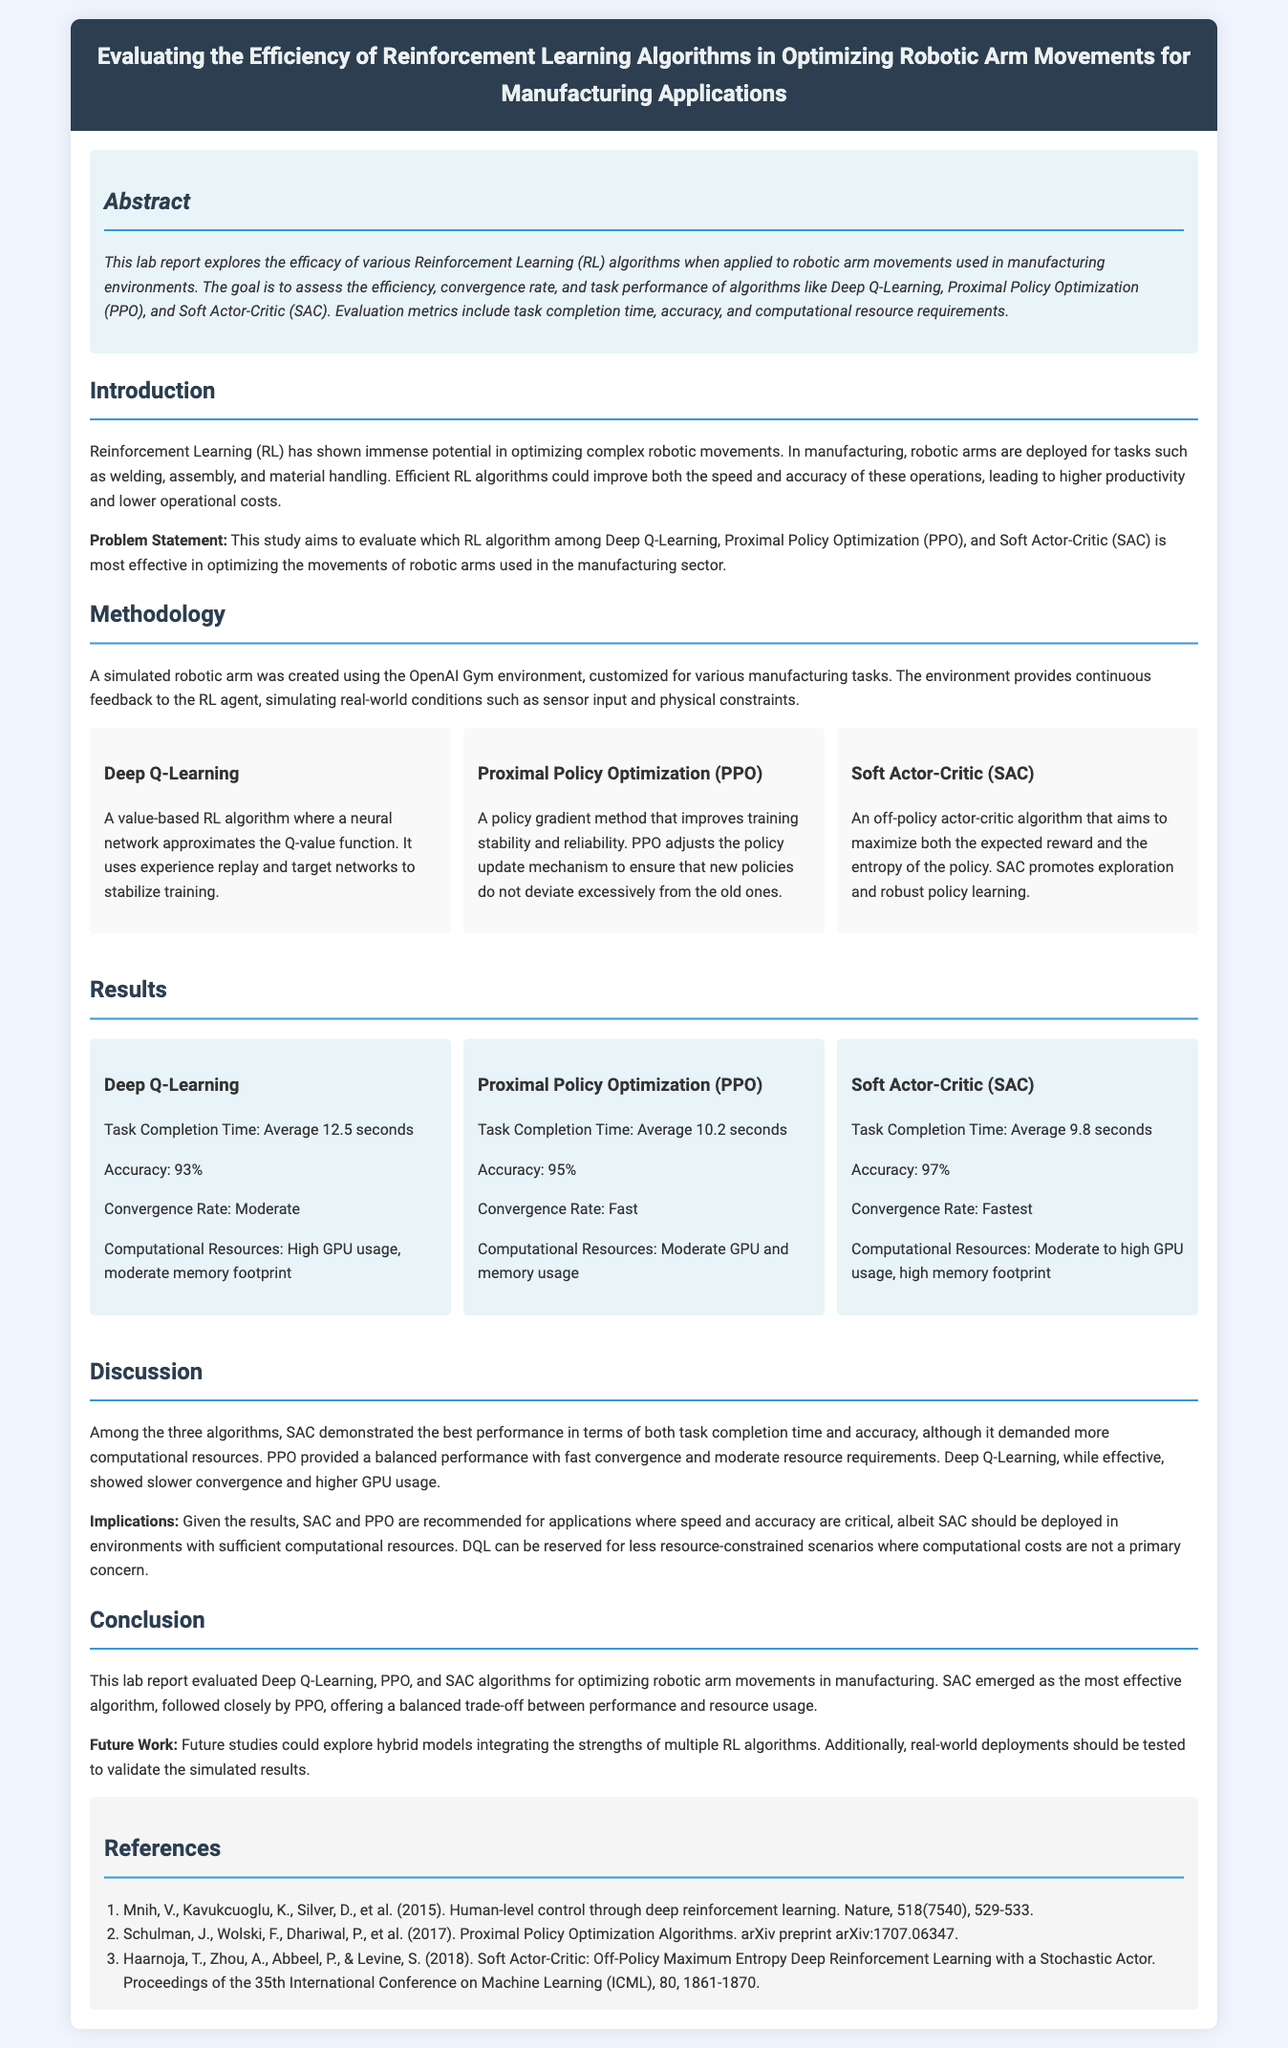What is the title of the lab report? The title of the lab report is stated at the top of the document.
Answer: Evaluating the Efficiency of Reinforcement Learning Algorithms in Optimizing Robotic Arm Movements for Manufacturing Applications What are the three algorithms evaluated in this report? The algorithms are mentioned in the Methodology section of the document.
Answer: Deep Q-Learning, Proximal Policy Optimization (PPO), Soft Actor-Critic (SAC) What was the average task completion time for Soft Actor-Critic? The average task completion time for SAC is found in the Results section of the document.
Answer: 9.8 seconds Which algorithm had the highest accuracy? The accuracy for each algorithm is listed in their respective result cards in the Results section.
Answer: Soft Actor-Critic (SAC) What is the recommended algorithm for limited computational resources? The recommendation is found in the Discussion section of the document when comparing the algorithms.
Answer: Deep Q-Learning What future work is suggested in the report? The Future Work section outlines the potential areas for further exploration in the study.
Answer: Hybrid models integrating the strengths of multiple RL algorithms What is the primary focus of the abstract? The abstract summarizes the aim and methods of the study, indicating the context of the research.
Answer: Efficacy of various Reinforcement Learning (RL) algorithms What does PPO stand for? The acronym for Proximal Policy Optimization is specified explicitly in the document.
Answer: Proximal Policy Optimization 